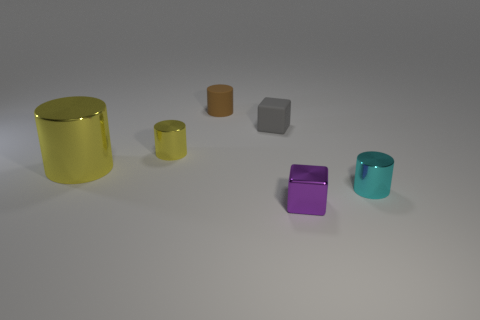There is a rubber object that is in front of the small rubber thing that is behind the block that is behind the tiny purple thing; what size is it?
Offer a very short reply. Small. Is the material of the small cylinder left of the brown cylinder the same as the tiny brown cylinder?
Provide a short and direct response. No. There is a small cylinder that is the same color as the big metallic thing; what is its material?
Offer a very short reply. Metal. Is there any other thing that has the same shape as the brown object?
Offer a very short reply. Yes. How many things are gray rubber cubes or red metal blocks?
Offer a terse response. 1. The other matte object that is the same shape as the cyan thing is what size?
Keep it short and to the point. Small. Is there anything else that is the same size as the brown matte cylinder?
Offer a very short reply. Yes. What number of other objects are there of the same color as the large cylinder?
Offer a very short reply. 1. How many cylinders are either small gray rubber objects or yellow objects?
Provide a short and direct response. 2. The metal cylinder that is to the right of the small metal object on the left side of the small purple metal object is what color?
Your answer should be very brief. Cyan. 